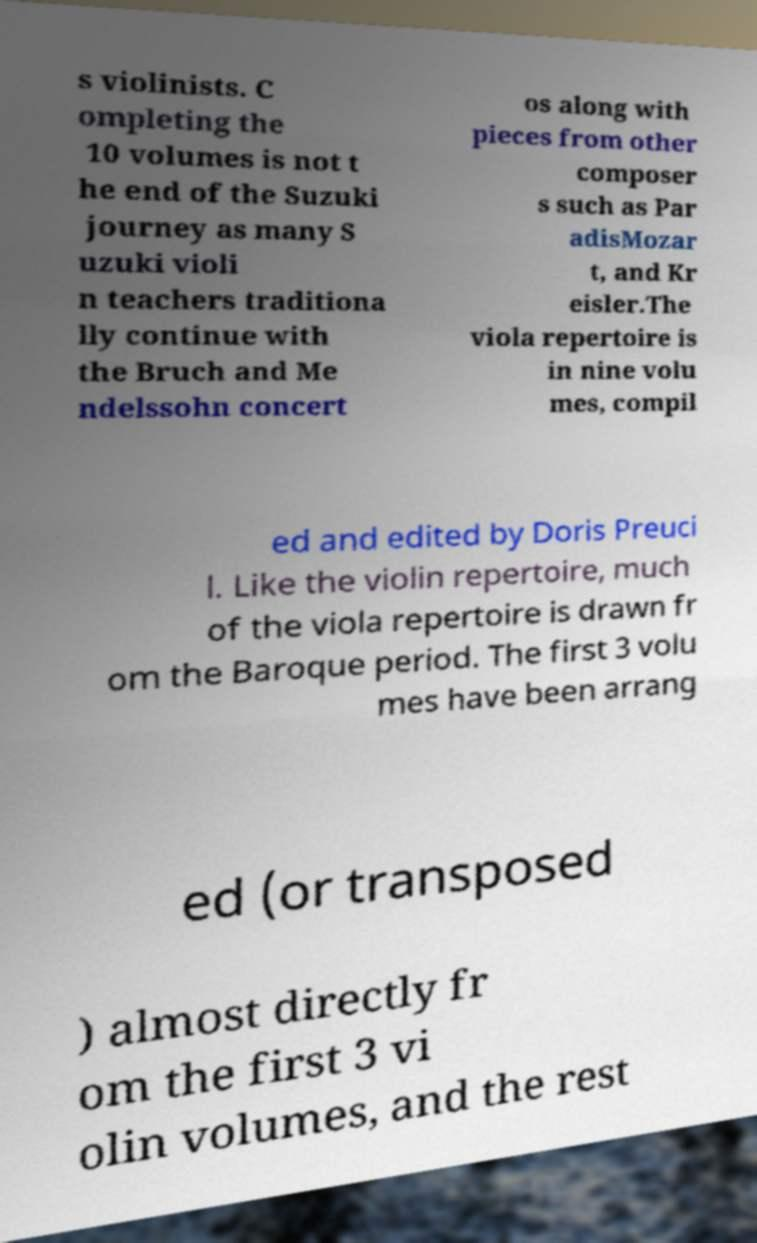Please identify and transcribe the text found in this image. s violinists. C ompleting the 10 volumes is not t he end of the Suzuki journey as many S uzuki violi n teachers traditiona lly continue with the Bruch and Me ndelssohn concert os along with pieces from other composer s such as Par adisMozar t, and Kr eisler.The viola repertoire is in nine volu mes, compil ed and edited by Doris Preuci l. Like the violin repertoire, much of the viola repertoire is drawn fr om the Baroque period. The first 3 volu mes have been arrang ed (or transposed ) almost directly fr om the first 3 vi olin volumes, and the rest 